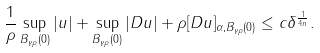<formula> <loc_0><loc_0><loc_500><loc_500>\frac { 1 } { \rho } \sup _ { B _ { \gamma \rho } ( 0 ) } | u | + \sup _ { B _ { \gamma \rho } ( 0 ) } | D u | + \rho [ D u ] _ { \alpha , B _ { \gamma \rho } ( 0 ) } \leq c \delta ^ { \frac { 1 } { 4 n } } .</formula> 